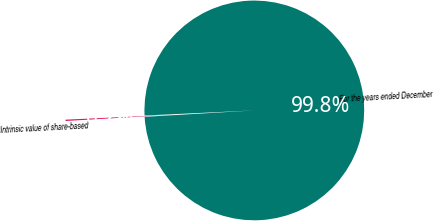Convert chart to OTSL. <chart><loc_0><loc_0><loc_500><loc_500><pie_chart><fcel>For the years ended December<fcel>Intrinsic value of share-based<nl><fcel>99.81%<fcel>0.19%<nl></chart> 